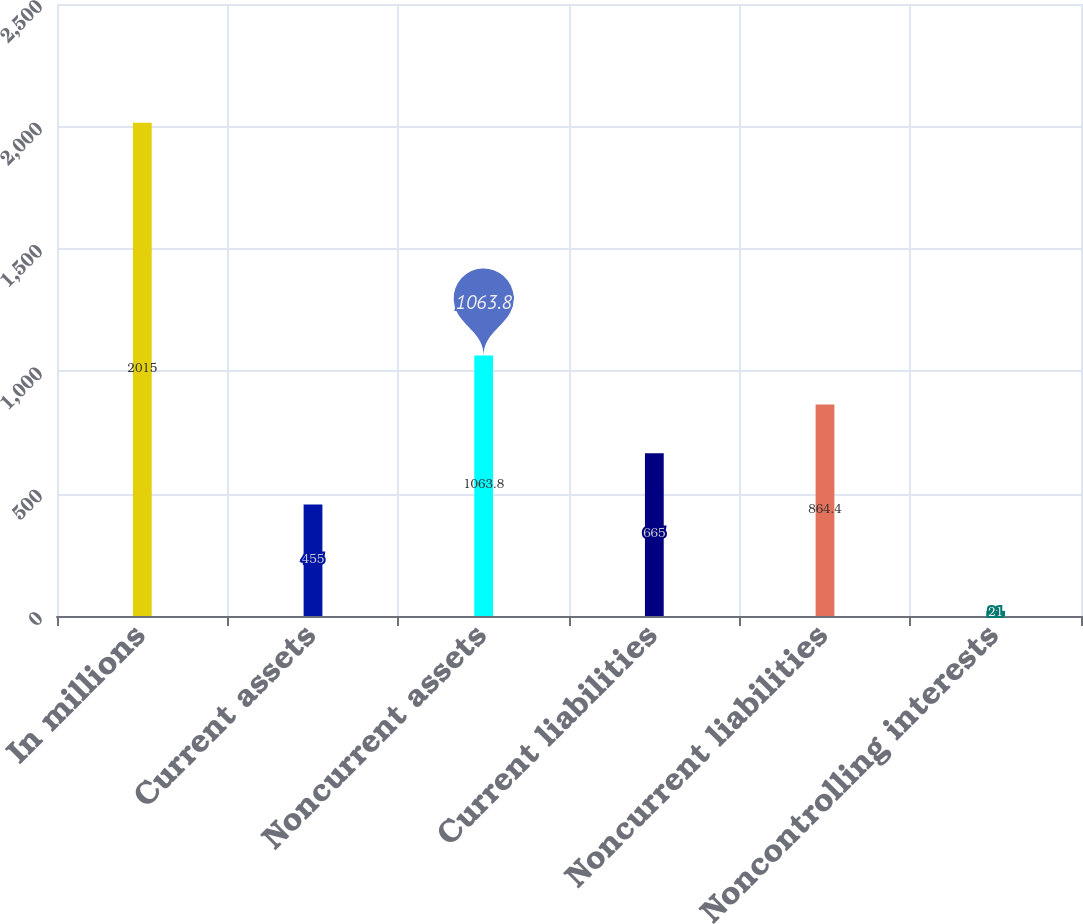<chart> <loc_0><loc_0><loc_500><loc_500><bar_chart><fcel>In millions<fcel>Current assets<fcel>Noncurrent assets<fcel>Current liabilities<fcel>Noncurrent liabilities<fcel>Noncontrolling interests<nl><fcel>2015<fcel>455<fcel>1063.8<fcel>665<fcel>864.4<fcel>21<nl></chart> 